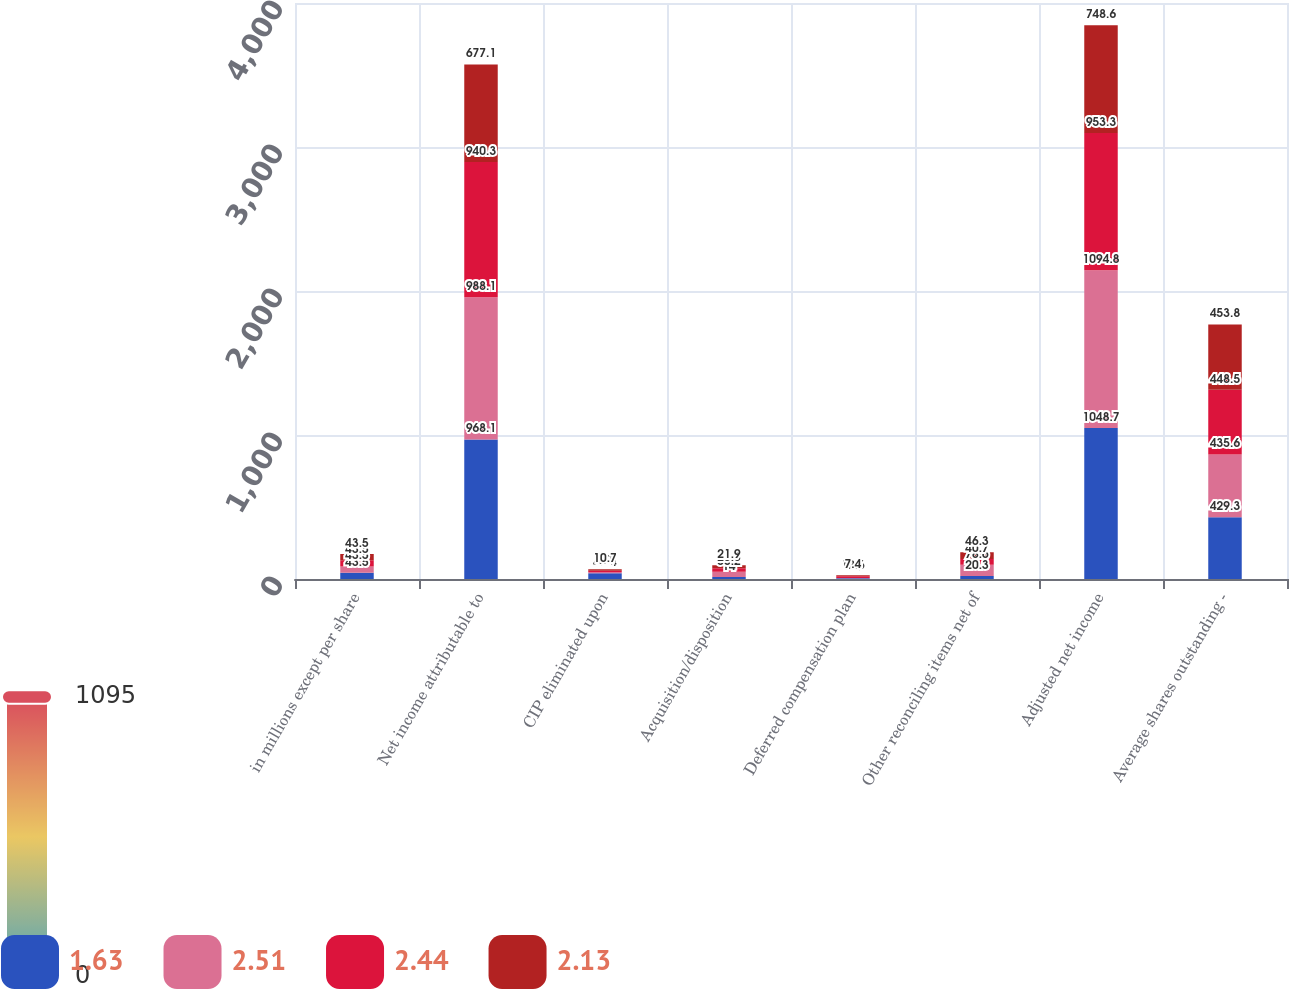Convert chart to OTSL. <chart><loc_0><loc_0><loc_500><loc_500><stacked_bar_chart><ecel><fcel>in millions except per share<fcel>Net income attributable to<fcel>CIP eliminated upon<fcel>Acquisition/disposition<fcel>Deferred compensation plan<fcel>Other reconciling items net of<fcel>Adjusted net income<fcel>Average shares outstanding -<nl><fcel>1.63<fcel>43.5<fcel>968.1<fcel>40.4<fcel>14<fcel>5.9<fcel>20.3<fcel>1048.7<fcel>429.3<nl><fcel>2.51<fcel>43.5<fcel>988.1<fcel>7.8<fcel>36.2<fcel>0.3<fcel>78.6<fcel>1094.8<fcel>435.6<nl><fcel>2.44<fcel>43.5<fcel>940.3<fcel>8.7<fcel>23.8<fcel>12.6<fcel>40.7<fcel>953.3<fcel>448.5<nl><fcel>2.13<fcel>43.5<fcel>677.1<fcel>10.7<fcel>21.9<fcel>7.4<fcel>46.3<fcel>748.6<fcel>453.8<nl></chart> 